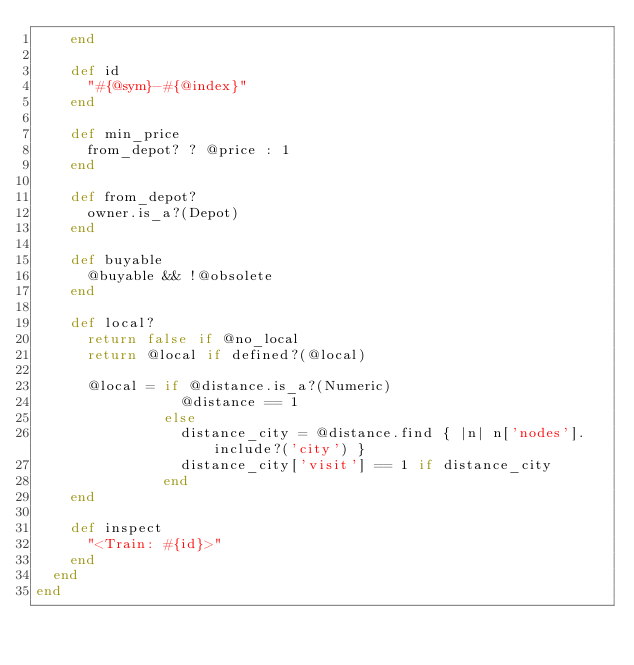Convert code to text. <code><loc_0><loc_0><loc_500><loc_500><_Ruby_>    end

    def id
      "#{@sym}-#{@index}"
    end

    def min_price
      from_depot? ? @price : 1
    end

    def from_depot?
      owner.is_a?(Depot)
    end

    def buyable
      @buyable && !@obsolete
    end

    def local?
      return false if @no_local
      return @local if defined?(@local)

      @local = if @distance.is_a?(Numeric)
                 @distance == 1
               else
                 distance_city = @distance.find { |n| n['nodes'].include?('city') }
                 distance_city['visit'] == 1 if distance_city
               end
    end

    def inspect
      "<Train: #{id}>"
    end
  end
end
</code> 